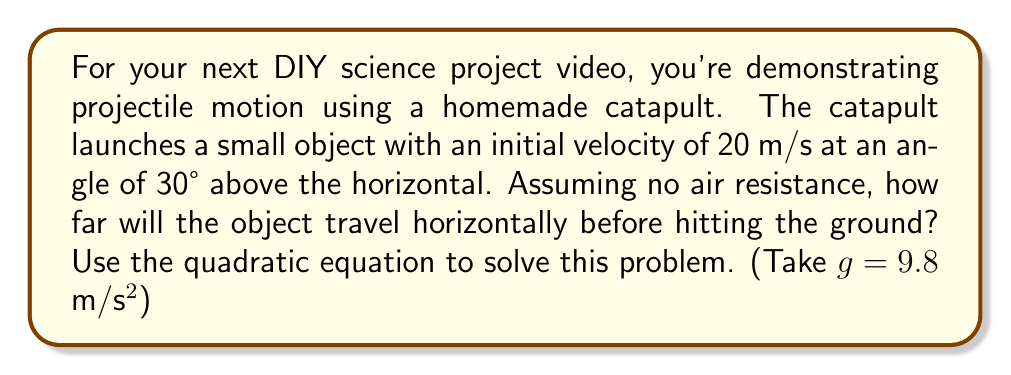Provide a solution to this math problem. Let's approach this step-by-step:

1) First, we need to recall the equations for projectile motion:

   Horizontal motion: $x = v_0\cos\theta \cdot t$
   Vertical motion: $y = v_0\sin\theta \cdot t - \frac{1}{2}gt^2$

2) At the point where the object hits the ground, $y = 0$. We can use this to form our quadratic equation:

   $0 = v_0\sin\theta \cdot t - \frac{1}{2}gt^2$

3) Let's substitute our known values:
   $v_0 = 20$ m/s
   $\theta = 30°$
   $g = 9.8$ m/s²

   $0 = 20\sin(30°) \cdot t - \frac{1}{2}(9.8)t^2$

4) Simplify:
   $0 = 10 \cdot t - 4.9t^2$

5) Rearrange into standard form $(at^2 + bt + c = 0)$:
   $4.9t^2 - 10t = 0$

6) Factor out $t$:
   $t(4.9t - 10) = 0$

7) Solve for $t$:
   $t = 0$ or $t = \frac{10}{4.9} \approx 2.04$ seconds

   We discard $t = 0$ as it doesn't represent the time we're looking for.

8) Now that we know the time of flight, we can use the horizontal motion equation to find the distance:

   $x = v_0\cos\theta \cdot t$
   $x = 20\cos(30°) \cdot 2.04$
   $x = 20 \cdot \frac{\sqrt{3}}{2} \cdot 2.04$
   $x \approx 35.3$ m

Therefore, the object will travel approximately 35.3 meters horizontally before hitting the ground.
Answer: 35.3 m 